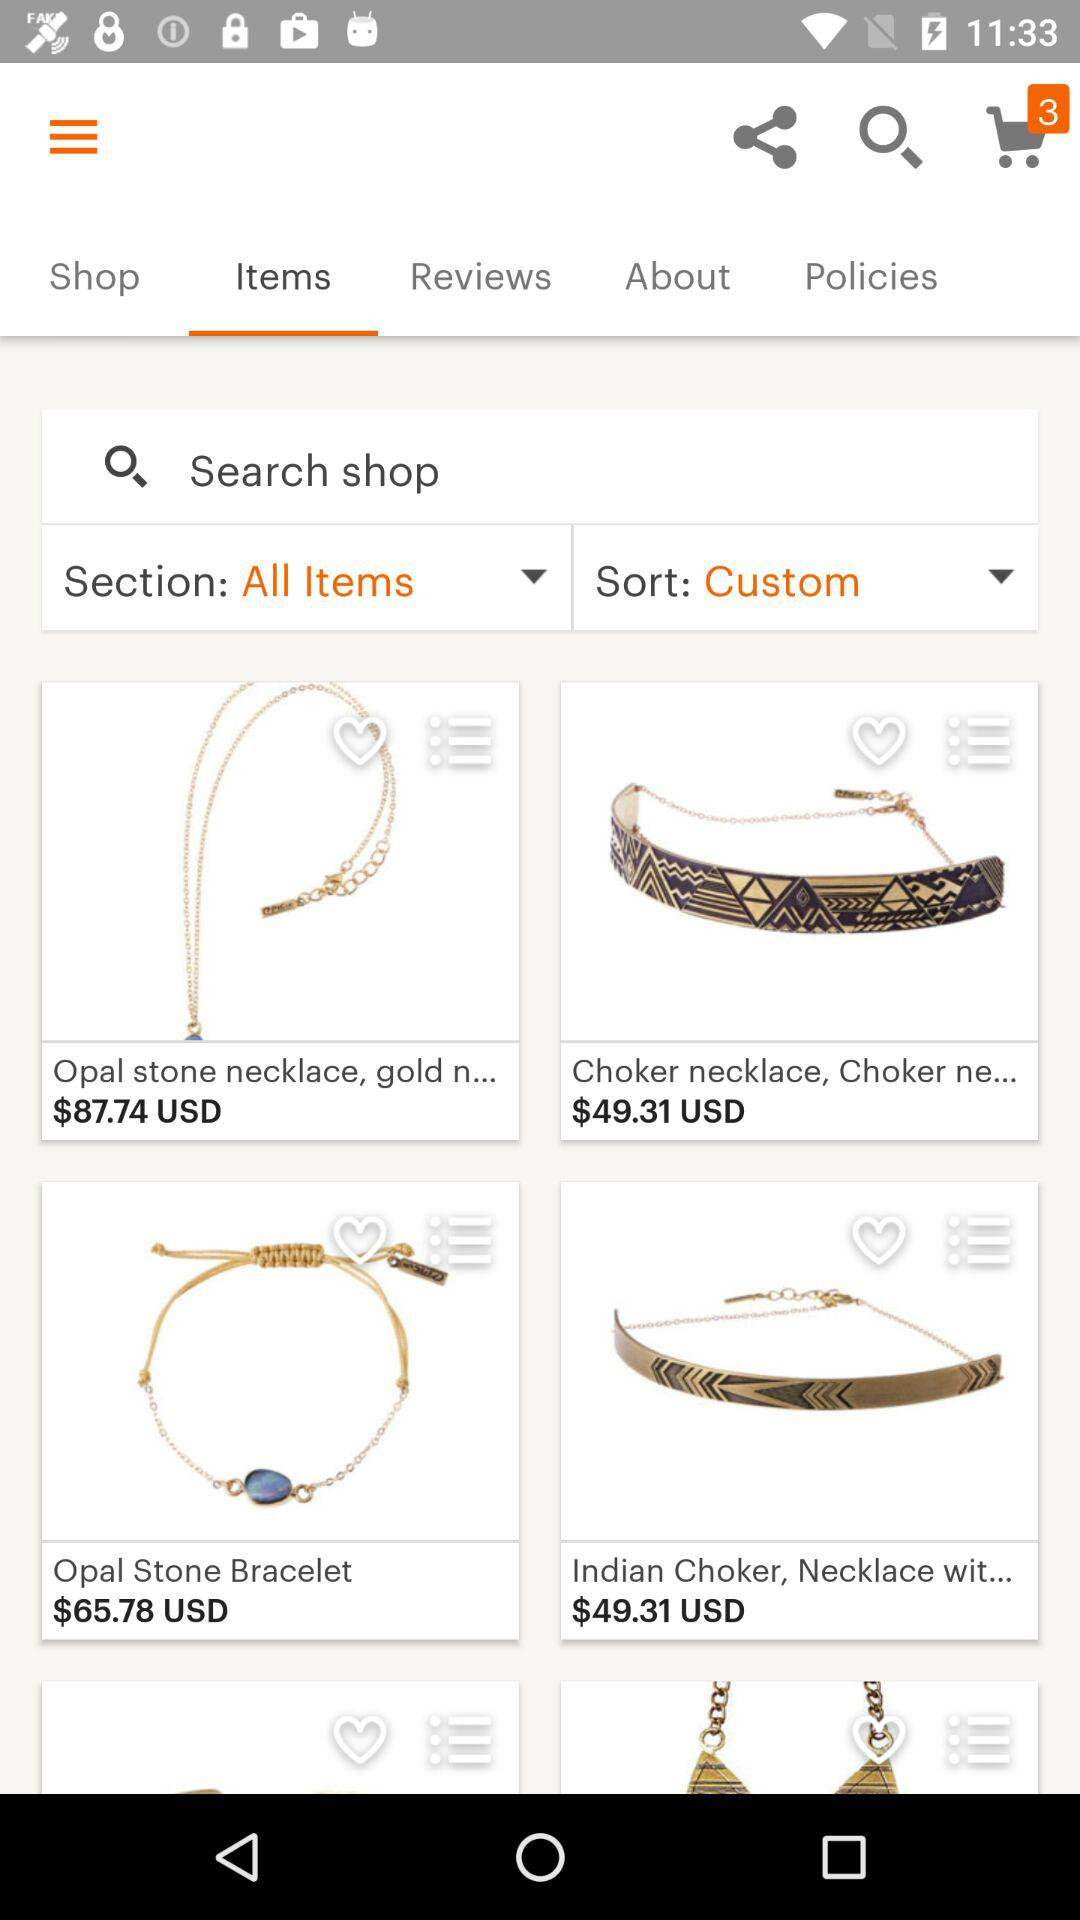What is the price of the opal stone bracelet? The price is $65.78 USD. 